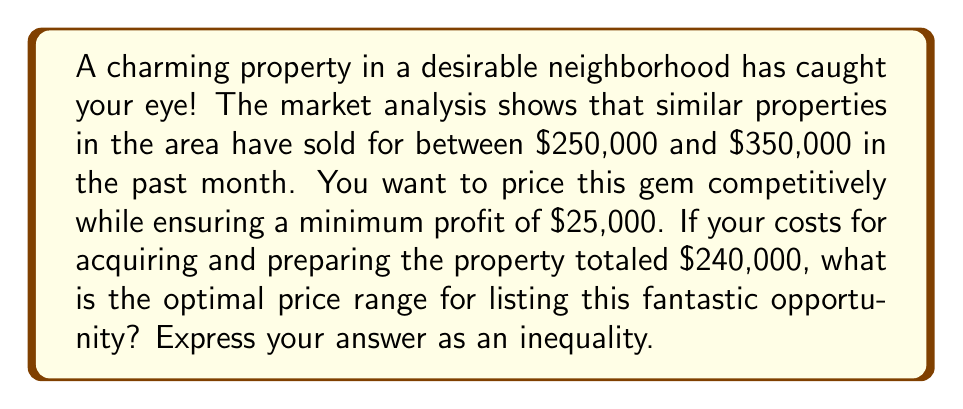Solve this math problem. Let's approach this step-by-step:

1) Define the variable:
   Let $x$ be the listing price of the property.

2) Consider the market conditions:
   The market range is $250,000 ≤ x ≤ $350,000

3) Calculate the minimum selling price to ensure profit:
   Minimum selling price = Cost + Minimum profit
   $240,000 + $25,000 = $265,000

4) Combine the constraints:
   The price should be at least $265,000 to ensure profit, but not more than $350,000 to stay within market range.

5) Express as an inequality:
   $$265,000 ≤ x ≤ 350,000$$

This inequality represents the optimal price range for the property, balancing profitability with market competitiveness.
Answer: $265,000 ≤ x ≤ 350,000$ 